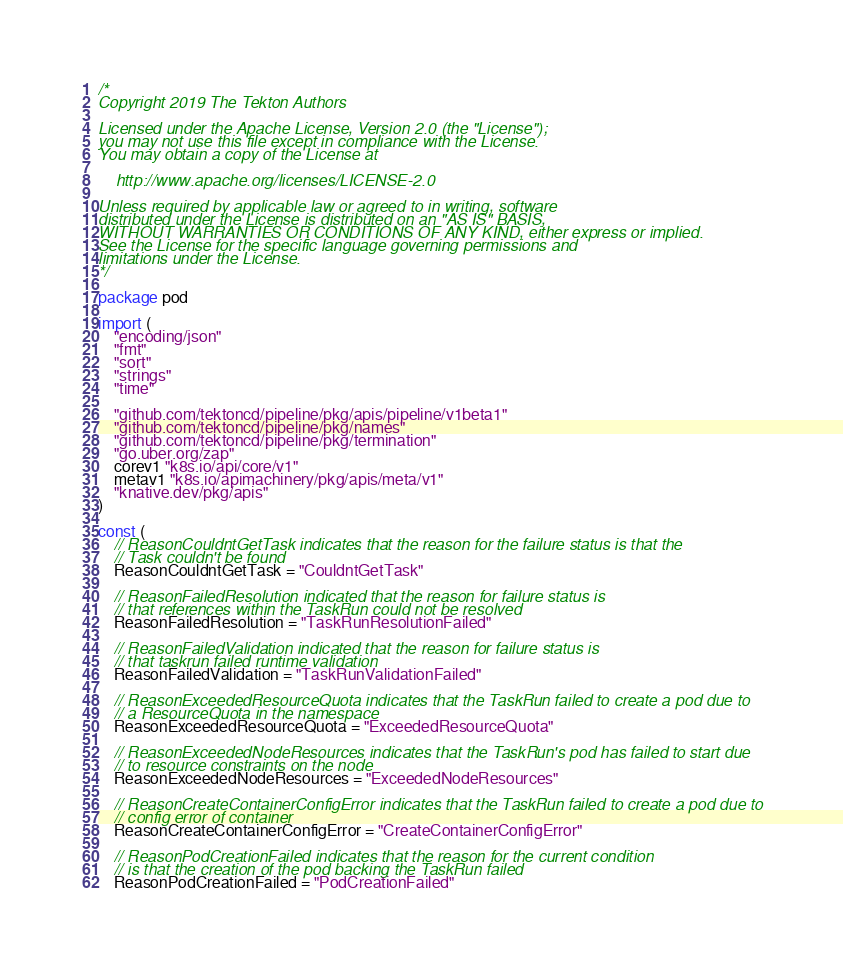<code> <loc_0><loc_0><loc_500><loc_500><_Go_>/*
Copyright 2019 The Tekton Authors

Licensed under the Apache License, Version 2.0 (the "License");
you may not use this file except in compliance with the License.
You may obtain a copy of the License at

    http://www.apache.org/licenses/LICENSE-2.0

Unless required by applicable law or agreed to in writing, software
distributed under the License is distributed on an "AS IS" BASIS,
WITHOUT WARRANTIES OR CONDITIONS OF ANY KIND, either express or implied.
See the License for the specific language governing permissions and
limitations under the License.
*/

package pod

import (
	"encoding/json"
	"fmt"
	"sort"
	"strings"
	"time"

	"github.com/tektoncd/pipeline/pkg/apis/pipeline/v1beta1"
	"github.com/tektoncd/pipeline/pkg/names"
	"github.com/tektoncd/pipeline/pkg/termination"
	"go.uber.org/zap"
	corev1 "k8s.io/api/core/v1"
	metav1 "k8s.io/apimachinery/pkg/apis/meta/v1"
	"knative.dev/pkg/apis"
)

const (
	// ReasonCouldntGetTask indicates that the reason for the failure status is that the
	// Task couldn't be found
	ReasonCouldntGetTask = "CouldntGetTask"

	// ReasonFailedResolution indicated that the reason for failure status is
	// that references within the TaskRun could not be resolved
	ReasonFailedResolution = "TaskRunResolutionFailed"

	// ReasonFailedValidation indicated that the reason for failure status is
	// that taskrun failed runtime validation
	ReasonFailedValidation = "TaskRunValidationFailed"

	// ReasonExceededResourceQuota indicates that the TaskRun failed to create a pod due to
	// a ResourceQuota in the namespace
	ReasonExceededResourceQuota = "ExceededResourceQuota"

	// ReasonExceededNodeResources indicates that the TaskRun's pod has failed to start due
	// to resource constraints on the node
	ReasonExceededNodeResources = "ExceededNodeResources"

	// ReasonCreateContainerConfigError indicates that the TaskRun failed to create a pod due to
	// config error of container
	ReasonCreateContainerConfigError = "CreateContainerConfigError"

	// ReasonPodCreationFailed indicates that the reason for the current condition
	// is that the creation of the pod backing the TaskRun failed
	ReasonPodCreationFailed = "PodCreationFailed"
</code> 